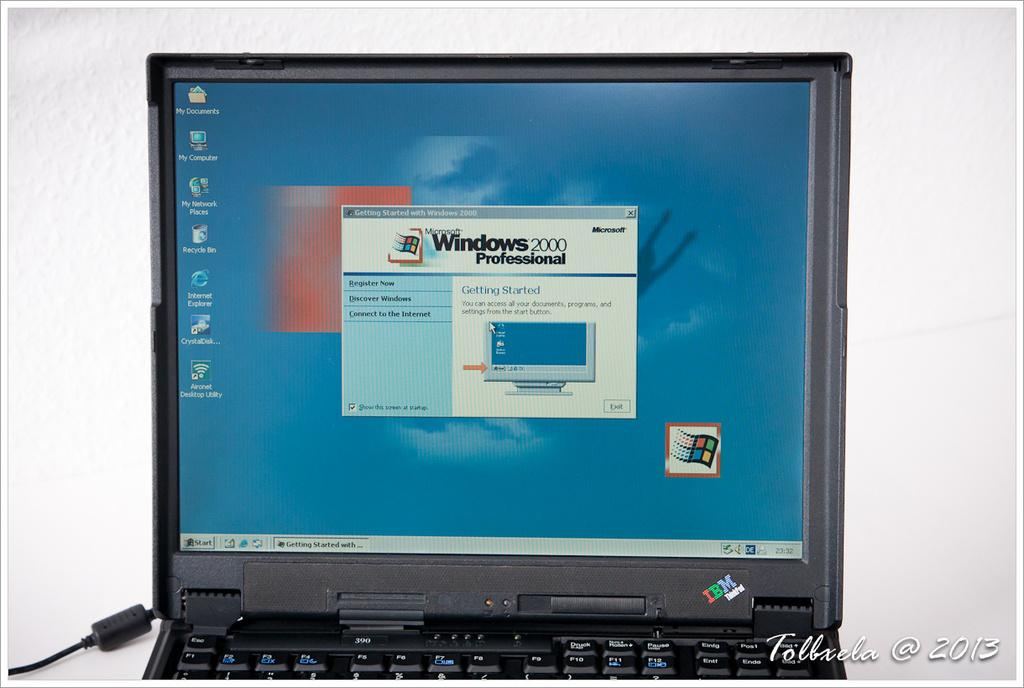What is the main subject of the image? There is a picture of a laptop in the image. Where is the laptop located in the image? The laptop is in the middle of the image. What color is the wall in the background of the image? There is a white color wall in the background of the image. Can you describe any additional features of the image? There is a watermark at the bottom of the image. What type of branch can be seen growing from the laptop in the image? There is no branch growing from the laptop in the image; it is a picture of a laptop without any plants or branches. What kind of trip is the laptop taking in the image? The laptop is not taking a trip in the image; it is a still image of a laptop on a surface. 